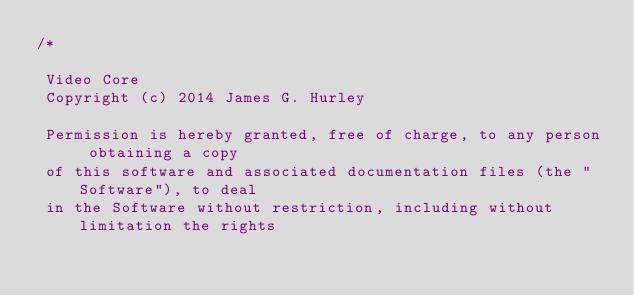<code> <loc_0><loc_0><loc_500><loc_500><_ObjectiveC_>/*
 
 Video Core
 Copyright (c) 2014 James G. Hurley
 
 Permission is hereby granted, free of charge, to any person obtaining a copy
 of this software and associated documentation files (the "Software"), to deal
 in the Software without restriction, including without limitation the rights</code> 